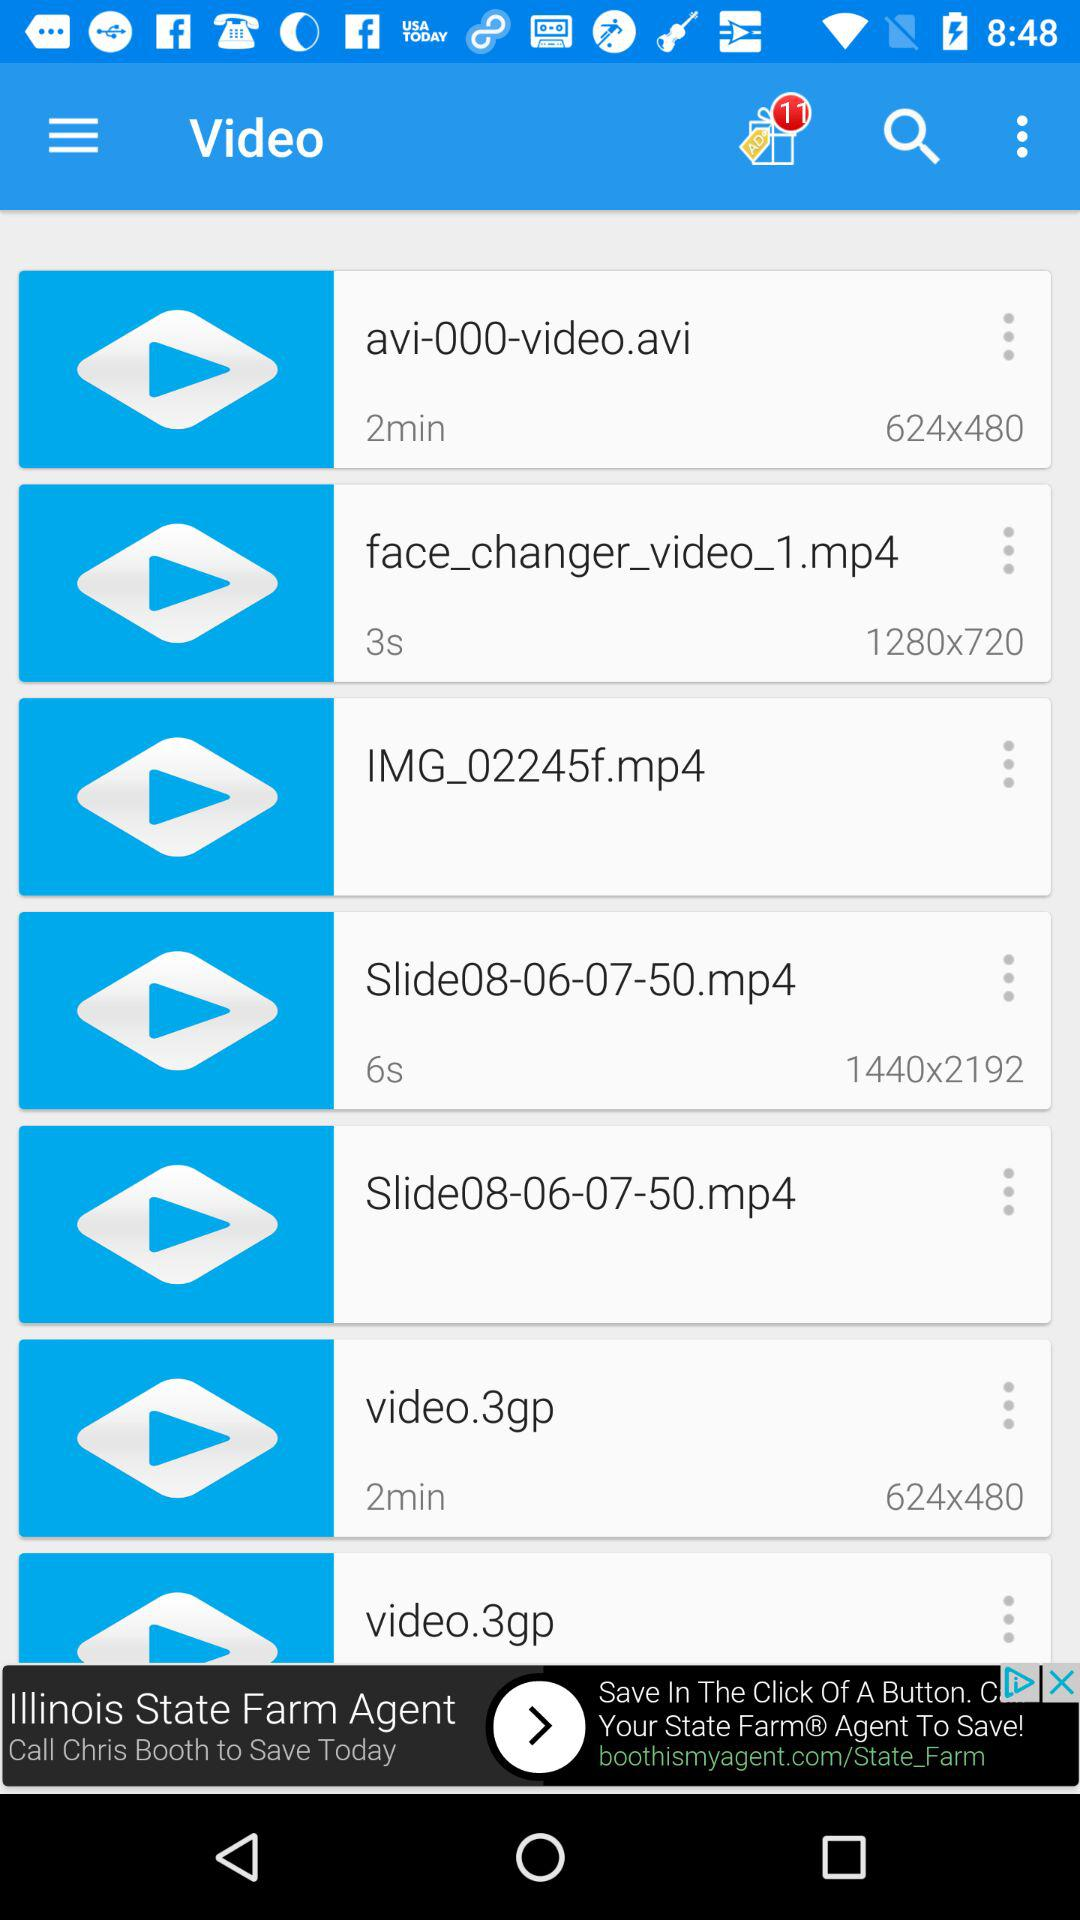What is the video time?
When the provided information is insufficient, respond with <no answer>. <no answer> 